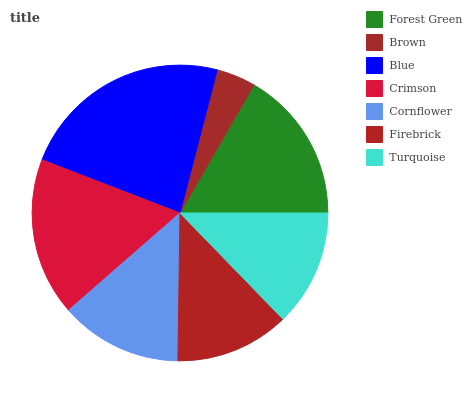Is Brown the minimum?
Answer yes or no. Yes. Is Blue the maximum?
Answer yes or no. Yes. Is Blue the minimum?
Answer yes or no. No. Is Brown the maximum?
Answer yes or no. No. Is Blue greater than Brown?
Answer yes or no. Yes. Is Brown less than Blue?
Answer yes or no. Yes. Is Brown greater than Blue?
Answer yes or no. No. Is Blue less than Brown?
Answer yes or no. No. Is Cornflower the high median?
Answer yes or no. Yes. Is Cornflower the low median?
Answer yes or no. Yes. Is Forest Green the high median?
Answer yes or no. No. Is Blue the low median?
Answer yes or no. No. 